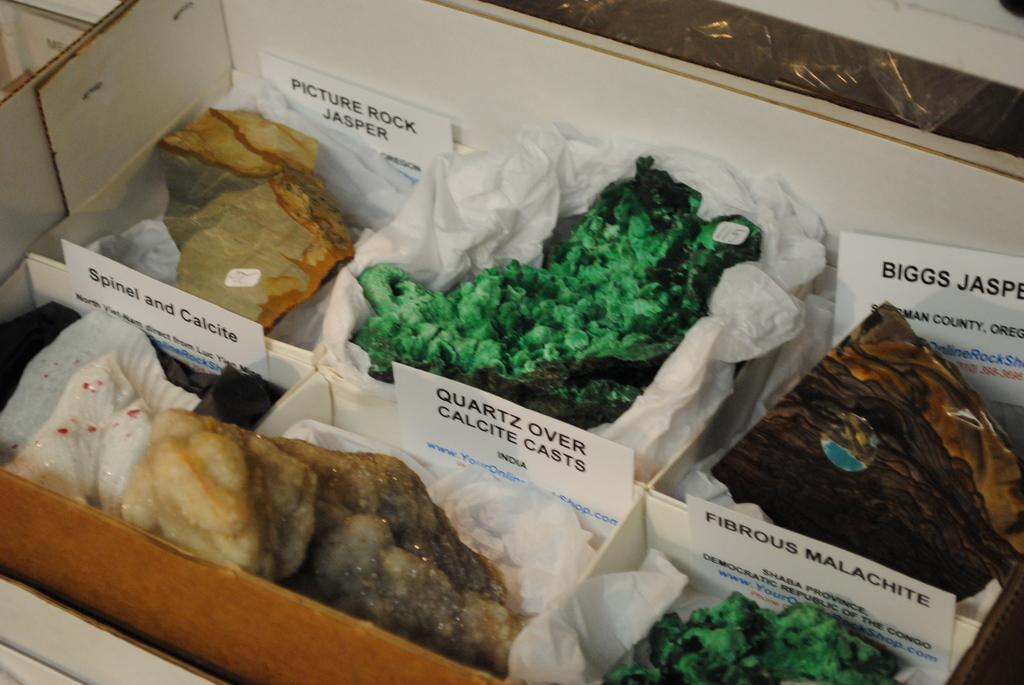What objects are present in the image? There are small boxes in the image. What is inside the small boxes? There are food items kept in the boxes. Can you see a girl pulling someone's nose in the image? There is no girl or any action of pulling someone's nose present in the image. 